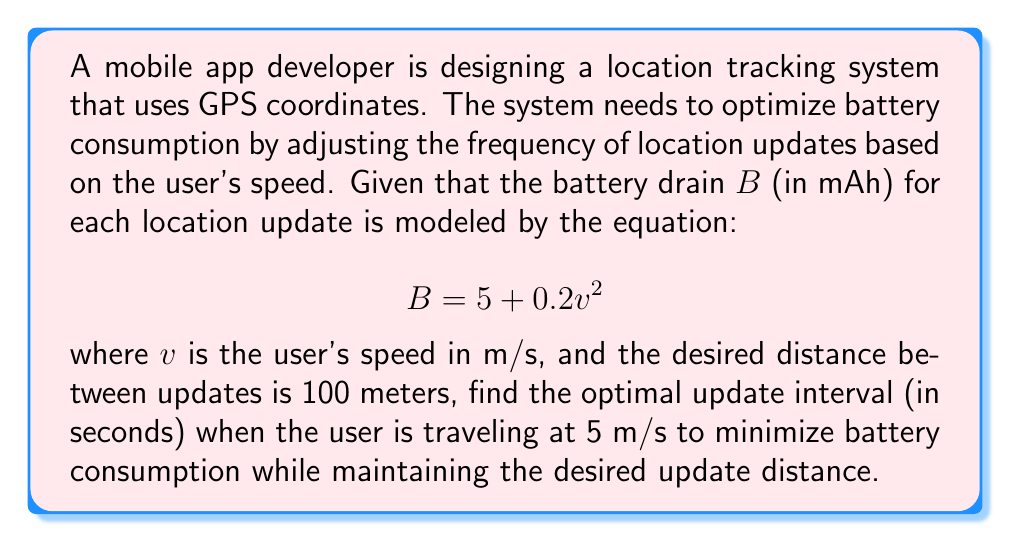Can you solve this math problem? Let's approach this step-by-step:

1) First, we need to understand what we're trying to optimize. We want to minimize battery consumption while maintaining updates every 100 meters.

2) Given the user's speed $v = 5$ m/s, we can calculate the time it takes to travel 100 meters:

   $$t = \frac{distance}{speed} = \frac{100}{5} = 20 \text{ seconds}$$

3) This means our update interval should be 20 seconds to maintain the 100-meter update distance.

4) Now, let's calculate the battery drain for a single update at this speed:

   $$B = 5 + 0.2v^2 = 5 + 0.2(5^2) = 5 + 5 = 10 \text{ mAh}$$

5) To find the battery drain per minute, we need to know how many updates occur in a minute:

   $$\text{Updates per minute} = \frac{60 \text{ seconds}}{20 \text{ seconds per update}} = 3 \text{ updates}$$

6) So the battery drain per minute is:

   $$\text{Battery drain per minute} = 10 \text{ mAh} \times 3 = 30 \text{ mAh/minute}$$

7) This update interval of 20 seconds is optimal because:
   - If we update more frequently, we would consume more battery without gaining significant location accuracy.
   - If we update less frequently, we would not meet the requirement of updating every 100 meters.

Therefore, the optimal update interval is 20 seconds.
Answer: 20 seconds 